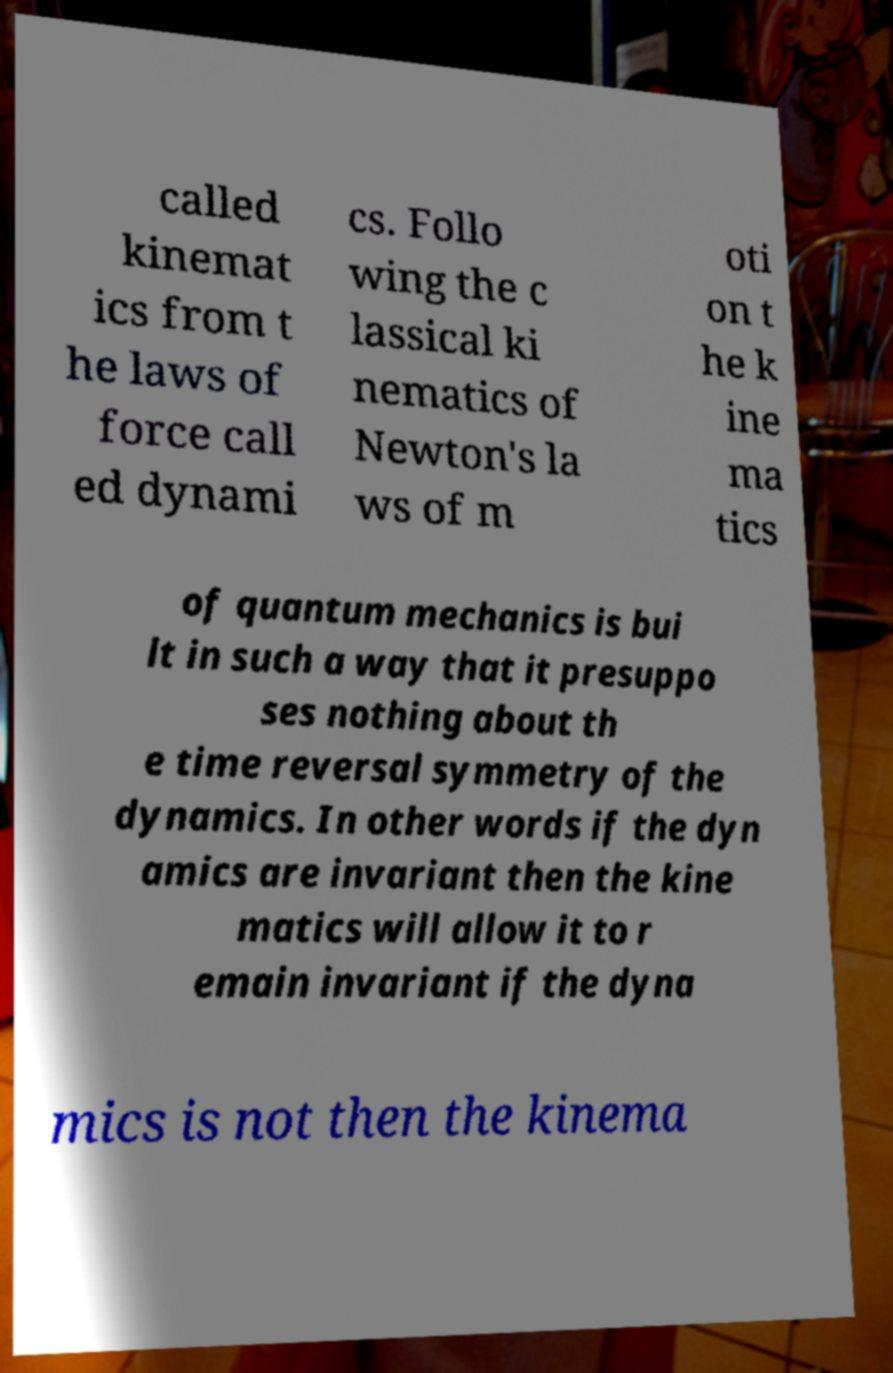Please identify and transcribe the text found in this image. called kinemat ics from t he laws of force call ed dynami cs. Follo wing the c lassical ki nematics of Newton's la ws of m oti on t he k ine ma tics of quantum mechanics is bui lt in such a way that it presuppo ses nothing about th e time reversal symmetry of the dynamics. In other words if the dyn amics are invariant then the kine matics will allow it to r emain invariant if the dyna mics is not then the kinema 